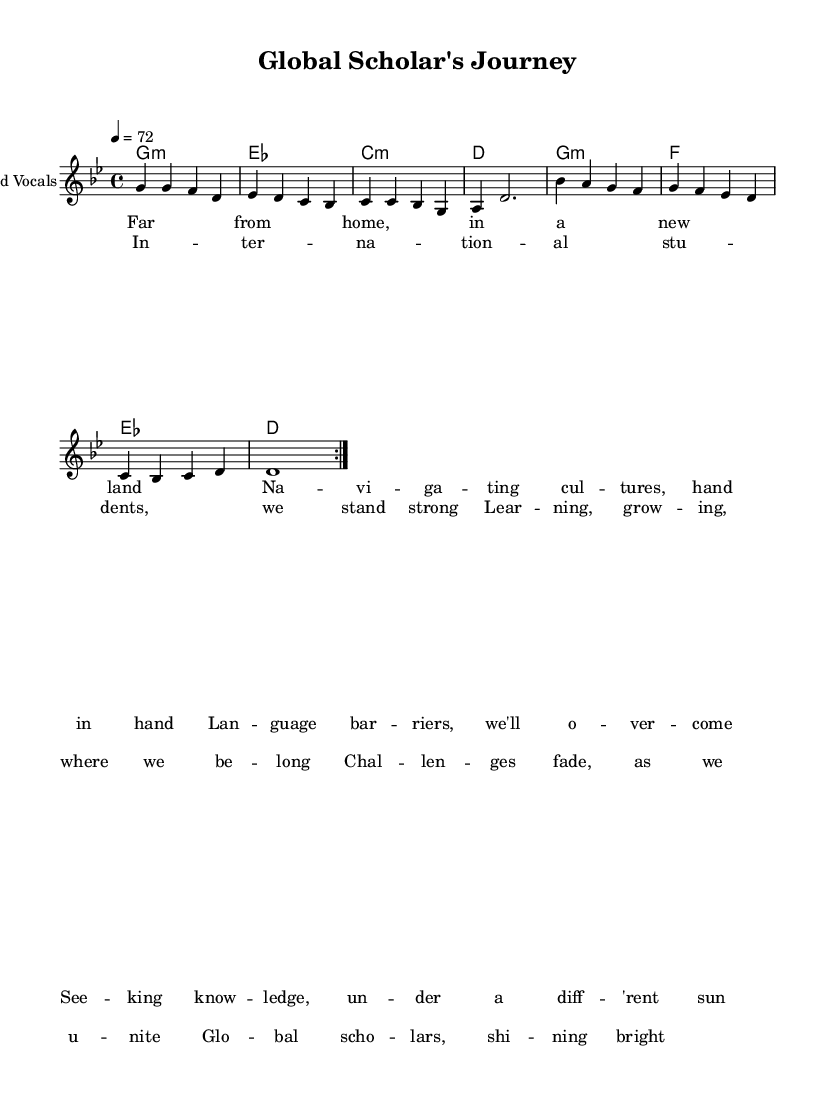What is the key signature of this music? The key signature is G minor, indicated by the presence of two flats (B flat and E flat) on the staff.
Answer: G minor What is the time signature of this piece? The time signature shown in the music is 4/4, meaning there are four beats in each measure and the quarter note gets one beat.
Answer: 4/4 What is the tempo marking for this piece? The tempo marking indicates that the piece should be played at a speed of 72 beats per minute, as noted at the beginning of the score.
Answer: 72 How many measures are in the melody section? By counting the measures in the melody, there are a total of 8 measures in the restatement of the melody before the chorus begins.
Answer: 8 What themes are explored in the lyrics? The lyrics discuss themes of cultural navigation, overcoming challenges, and unity among international students, reflecting their experiences.
Answer: Cultural navigation, challenges, unity What is the name of the song? The title of the song is "Global Scholar's Journey," as indicated in the header of the sheet music.
Answer: Global Scholar's Journey How does the structure of the song compare to typical reggae styles? This song includes verses and a chorus, which is common in reggae. However, it also highlights a narrative about the struggles of international students, a unique thematic element.
Answer: Verses and chorus 